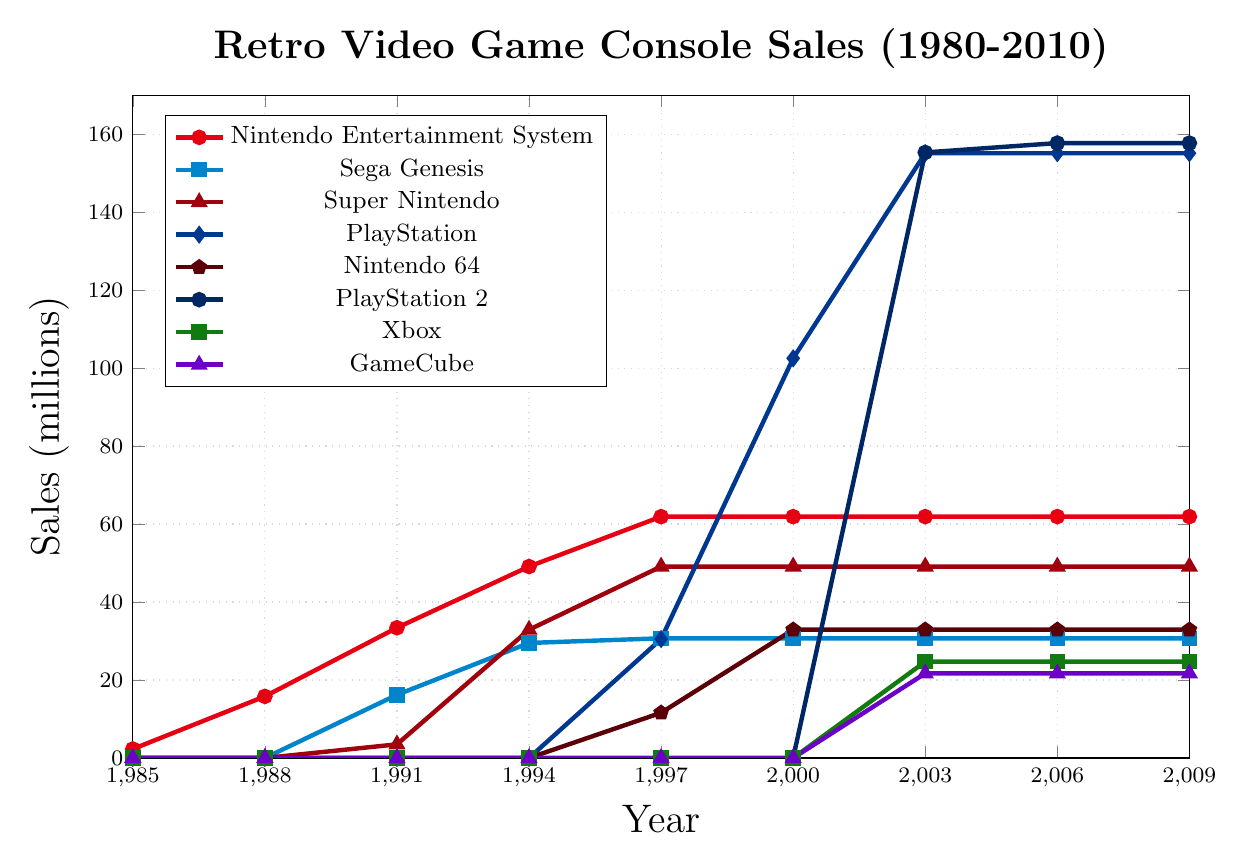What's the highest sales figure shown in the chart, and which console does it belong to? To find the highest sales figure, look for the peak of the lines. The PlayStation 2 reaches the highest point with sales of 157.7 million units in 2006 and 2009.
Answer: PlayStation 2 Which console had the steepest increase in sales between any two consecutive years? To determine this, examine the slopes of the lines between data points. The PlayStation had a sharp increase from 30.5 million in 1997 to 102.5 million in 2000, a rise of 72 million units in 3 years.
Answer: PlayStation What is the total sales of Nintendo Entertainment System and Sega Genesis in 1994? Add the sales figures of the two consoles in 1994: 49.1 million (Nintendo Entertainment System) + 29.5 million (Sega Genesis) = 78.6 million.
Answer: 78.6 million What year did the Super Nintendo surpass Sega Genesis in sales? Compare the lines for Super Nintendo and Sega Genesis. The Super Nintendo surpassed Sega Genesis in 1994.
Answer: 1994 Which console maintained the same sales figure from 2003 to 2009? Identify the lines that remain horizontal from 2003 to 2009. The Nintendo Entertainment System holds steady at 61.9 million units, Sega Genesis at 30.7 million units, and Nintendo 64 at 32.9 million units during this period.
Answer: Nintendo Entertainment System, Sega Genesis, Nintendo 64 Compare the sales of the original PlayStation to the Xbox in 2003. Which had higher sales and by how much? The PlayStation had sales of 155.1 million and the Xbox had 24.7 million in 2003. The PlayStation sales exceed those of the Xbox by 155.1 - 24.7 = 130.4 million units.
Answer: PlayStation, 130.4 million Which console saw no sales until after 2000? Identify the lines that start plotting after the year 2000. The Xbox and GameCube had no sales figures plotted before 2003.
Answer: Xbox, GameCube By how much did PlayStation sales grow between 1997 and 2003? Subtract the 1997 sales figure from the 2003 figure: 155.1 million - 30.5 million = 124.6 million.
Answer: 124.6 million What is the sales difference between Nintendo 64 and GameCube in 2003? Subtract GameCube sales from Nintendo 64 sales in 2003: 32.9 million - 21.7 million = 11.2 million.
Answer: 11.2 million 